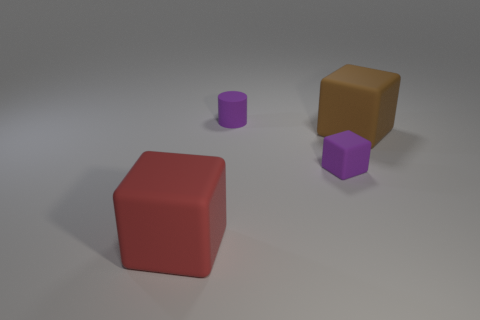Is the number of large rubber cubes that are in front of the large red rubber block less than the number of purple rubber objects in front of the brown rubber thing?
Offer a terse response. Yes. There is a small object behind the tiny purple cube; is its color the same as the small object that is in front of the big brown matte block?
Offer a terse response. Yes. What is the material of the thing that is both right of the purple matte cylinder and behind the tiny purple cube?
Make the answer very short. Rubber. Is there a large yellow shiny block?
Keep it short and to the point. No. There is a small thing that is the same material as the tiny purple block; what is its shape?
Provide a short and direct response. Cylinder. There is a large red rubber object; is it the same shape as the small matte thing behind the tiny rubber cube?
Offer a very short reply. No. How many other things are the same shape as the red thing?
Give a very brief answer. 2. Is the shape of the large matte object that is behind the tiny purple block the same as the big object to the left of the brown rubber block?
Give a very brief answer. Yes. There is a tiny thing that is behind the brown cube; what is it made of?
Your answer should be compact. Rubber. Is there any other thing that has the same color as the cylinder?
Your answer should be very brief. Yes. 